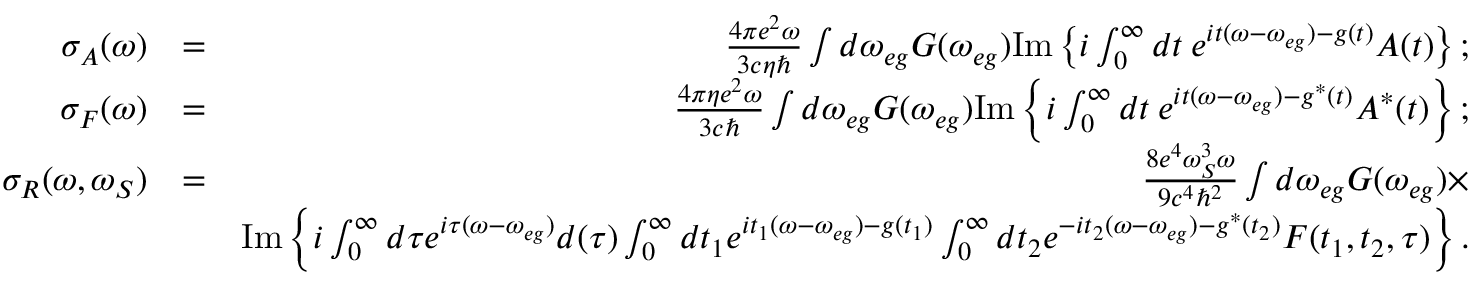Convert formula to latex. <formula><loc_0><loc_0><loc_500><loc_500>\begin{array} { r l r } { \sigma _ { A } ( \omega ) } & { = } & { \frac { 4 \pi e ^ { 2 } \omega } { 3 c \eta } \int d \omega _ { e g } G ( \omega _ { e g } ) I m \left \{ i \int _ { 0 } ^ { \infty } d t \, e ^ { i t ( \omega - \omega _ { e g } ) - g ( t ) } A ( t ) \right \} ; } \\ { \sigma _ { F } ( \omega ) } & { = } & { \frac { 4 \pi \eta e ^ { 2 } \omega } { 3 c } \int d \omega _ { e g } G ( \omega _ { e g } ) I m \left \{ i \int _ { 0 } ^ { \infty } d t \, e ^ { i t ( \omega - \omega _ { e g } ) - g ^ { * } ( t ) } A ^ { * } ( t ) \right \} ; } \\ { \sigma _ { R } ( \omega , \omega _ { S } ) } & { = } & { \frac { 8 e ^ { 4 } \omega _ { S } ^ { 3 } \omega } { 9 c ^ { 4 } \hbar { ^ } { 2 } } \int d \omega _ { e g } G ( \omega _ { e g } ) \times } \\ & { I m \left \{ i \int _ { 0 } ^ { \infty } d \tau e ^ { i \tau ( \omega - \omega _ { e g } ) } d ( \tau ) \int _ { 0 } ^ { \infty } d t _ { 1 } e ^ { i t _ { 1 } ( \omega - \omega _ { e g } ) - g ( t _ { 1 } ) } \int _ { 0 } ^ { \infty } d t _ { 2 } e ^ { - i t _ { 2 } ( \omega - \omega _ { e g } ) - g ^ { * } ( t _ { 2 } ) } F ( t _ { 1 } , t _ { 2 } , \tau ) \right \} . } \end{array}</formula> 